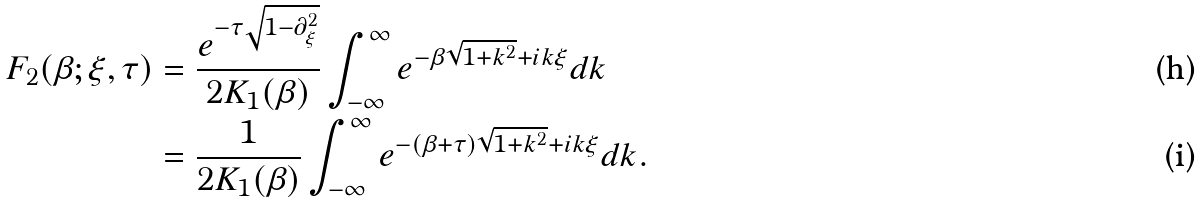<formula> <loc_0><loc_0><loc_500><loc_500>F _ { 2 } ( \beta ; \xi , \tau ) & = \frac { e ^ { - \tau \sqrt { 1 - \partial _ { \xi } ^ { 2 } } } } { 2 K _ { 1 } ( \beta ) } \int _ { - \infty } ^ { \infty } e ^ { - \beta \sqrt { 1 + k ^ { 2 } } + i k \xi } d k \\ & = \frac { 1 } { 2 K _ { 1 } ( \beta ) } \int _ { - \infty } ^ { \infty } e ^ { - ( \beta + \tau ) \sqrt { 1 + k ^ { 2 } } + i k \xi } d k .</formula> 